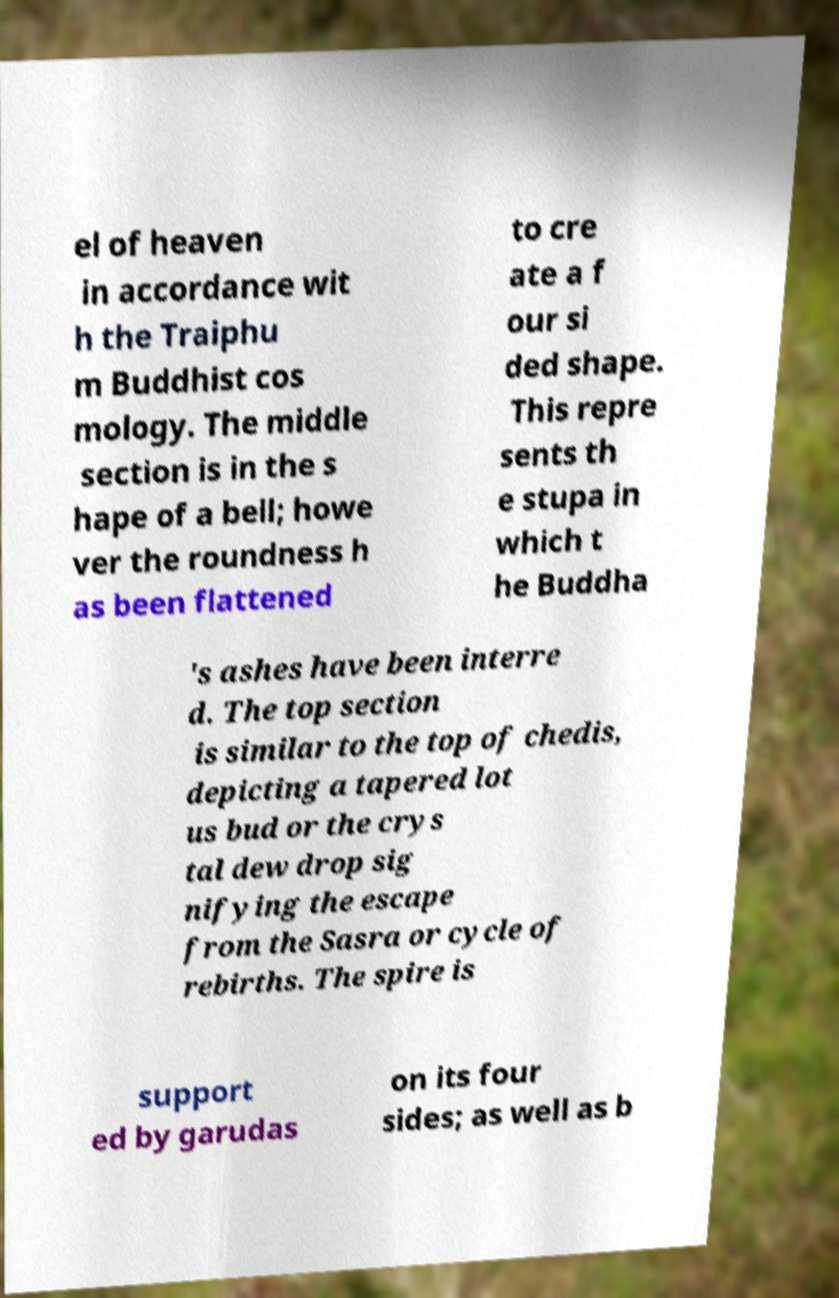Could you extract and type out the text from this image? el of heaven in accordance wit h the Traiphu m Buddhist cos mology. The middle section is in the s hape of a bell; howe ver the roundness h as been flattened to cre ate a f our si ded shape. This repre sents th e stupa in which t he Buddha 's ashes have been interre d. The top section is similar to the top of chedis, depicting a tapered lot us bud or the crys tal dew drop sig nifying the escape from the Sasra or cycle of rebirths. The spire is support ed by garudas on its four sides; as well as b 